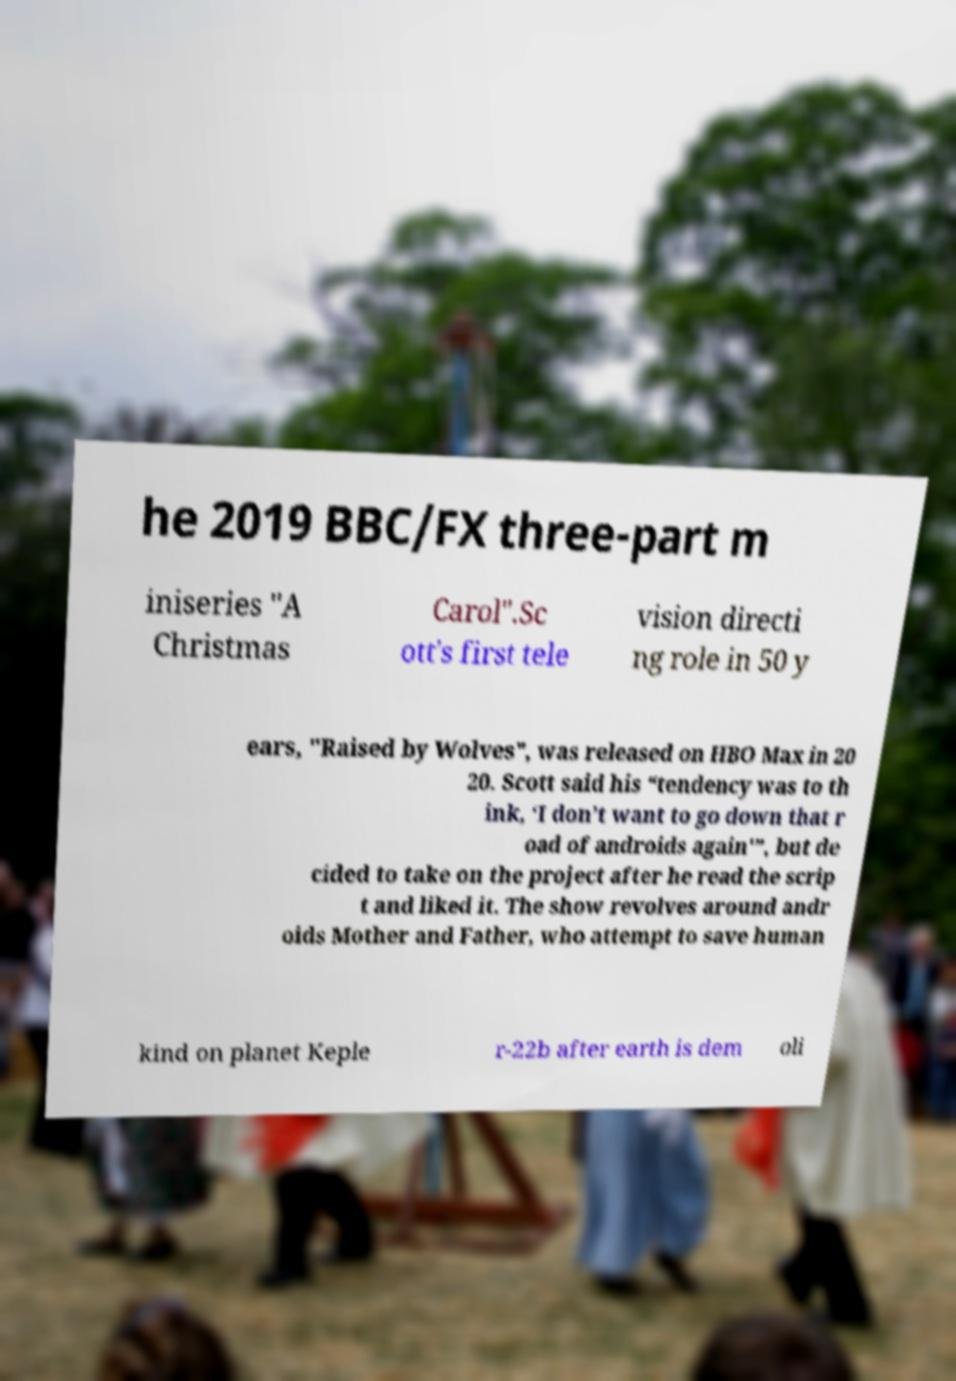For documentation purposes, I need the text within this image transcribed. Could you provide that? he 2019 BBC/FX three-part m iniseries "A Christmas Carol".Sc ott's first tele vision directi ng role in 50 y ears, "Raised by Wolves", was released on HBO Max in 20 20. Scott said his “tendency was to th ink, ‘I don’t want to go down that r oad of androids again'”, but de cided to take on the project after he read the scrip t and liked it. The show revolves around andr oids Mother and Father, who attempt to save human kind on planet Keple r-22b after earth is dem oli 